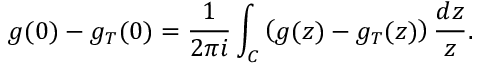Convert formula to latex. <formula><loc_0><loc_0><loc_500><loc_500>g ( 0 ) - g _ { T } ( 0 ) = { \frac { 1 } { 2 \pi i } } \int _ { C } \left ( g ( z ) - g _ { T } ( z ) \right ) { \frac { d z } { z } } .</formula> 